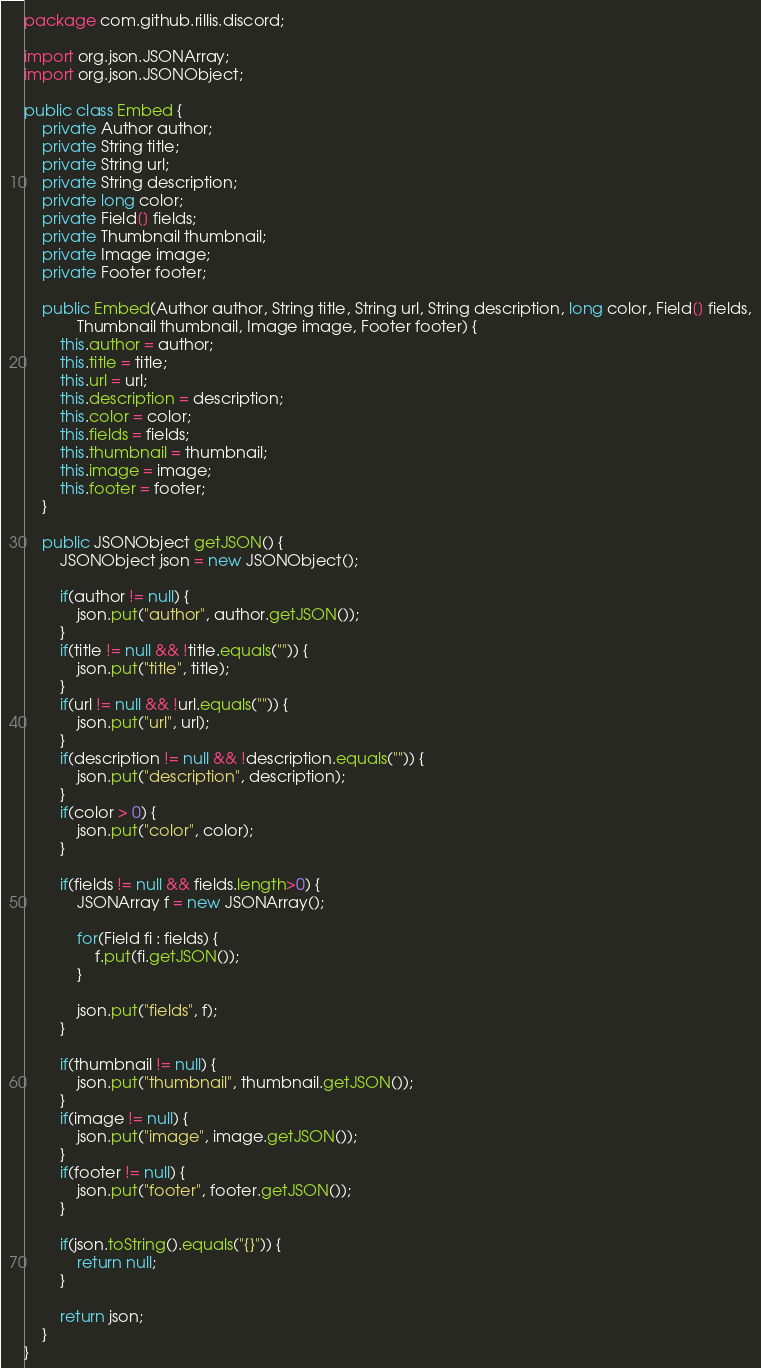Convert code to text. <code><loc_0><loc_0><loc_500><loc_500><_Java_>package com.github.rillis.discord;

import org.json.JSONArray;
import org.json.JSONObject;

public class Embed {
	private Author author;
	private String title;
	private String url;
	private String description;
	private long color;
	private Field[] fields;
	private Thumbnail thumbnail;
	private Image image;
	private Footer footer;
	
	public Embed(Author author, String title, String url, String description, long color, Field[] fields,
			Thumbnail thumbnail, Image image, Footer footer) {
		this.author = author;
		this.title = title;
		this.url = url;
		this.description = description;
		this.color = color;
		this.fields = fields;
		this.thumbnail = thumbnail;
		this.image = image;
		this.footer = footer;
	}

	public JSONObject getJSON() {		
		JSONObject json = new JSONObject();
		
		if(author != null) {
			json.put("author", author.getJSON());
		}
		if(title != null && !title.equals("")) {
			json.put("title", title);
		}
		if(url != null && !url.equals("")) {
			json.put("url", url);
		}
		if(description != null && !description.equals("")) {
			json.put("description", description);
		}
		if(color > 0) {
			json.put("color", color);
		}
		
		if(fields != null && fields.length>0) {
			JSONArray f = new JSONArray();
			
			for(Field fi : fields) {
				f.put(fi.getJSON());
			}
			
			json.put("fields", f);
		}
		
		if(thumbnail != null) {
			json.put("thumbnail", thumbnail.getJSON());
		}
		if(image != null) {
			json.put("image", image.getJSON());
		}
		if(footer != null) {
			json.put("footer", footer.getJSON());
		}
		
		if(json.toString().equals("{}")) {
			return null;
		}
		
		return json;
	}
}
</code> 